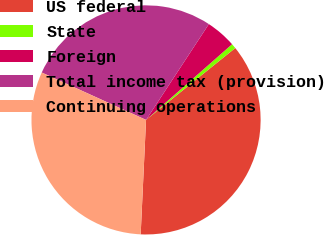Convert chart. <chart><loc_0><loc_0><loc_500><loc_500><pie_chart><fcel>US federal<fcel>State<fcel>Foreign<fcel>Total income tax (provision)<fcel>Continuing operations<nl><fcel>36.54%<fcel>0.69%<fcel>4.28%<fcel>27.45%<fcel>31.04%<nl></chart> 